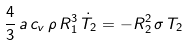<formula> <loc_0><loc_0><loc_500><loc_500>\frac { 4 } { 3 } \, a \, c _ { v } \, \rho \, R _ { 1 } ^ { 3 } \, \dot { T } _ { 2 } = - R _ { 2 } ^ { 2 } \, \sigma \, T _ { 2 }</formula> 